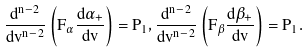Convert formula to latex. <formula><loc_0><loc_0><loc_500><loc_500>\frac { d ^ { n - 2 } } { d v ^ { n - 2 } } \left ( F _ { \alpha } \frac { d \alpha _ { + } } { d v } \right ) = P _ { 1 } , \frac { d ^ { n - 2 } } { d v ^ { n - 2 } } \left ( F _ { \beta } \frac { d \beta _ { + } } { d v } \right ) = P _ { 1 } .</formula> 